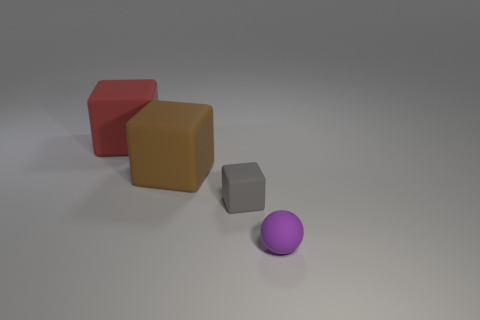What is the tiny object behind the purple ball made of?
Ensure brevity in your answer.  Rubber. Do the purple thing and the matte thing behind the brown block have the same shape?
Keep it short and to the point. No. What number of tiny purple rubber objects are behind the tiny object in front of the small rubber thing behind the purple ball?
Provide a succinct answer. 0. The other large rubber thing that is the same shape as the red thing is what color?
Ensure brevity in your answer.  Brown. Is there any other thing that is the same shape as the tiny purple thing?
Your answer should be compact. No. What number of cylinders are either purple rubber things or big red objects?
Provide a succinct answer. 0. What is the shape of the big brown rubber object?
Give a very brief answer. Cube. There is a sphere; are there any large objects behind it?
Provide a succinct answer. Yes. Does the large brown thing have the same material as the small object that is behind the small purple thing?
Your response must be concise. Yes. Do the tiny object that is on the left side of the tiny purple thing and the red rubber object have the same shape?
Ensure brevity in your answer.  Yes. 